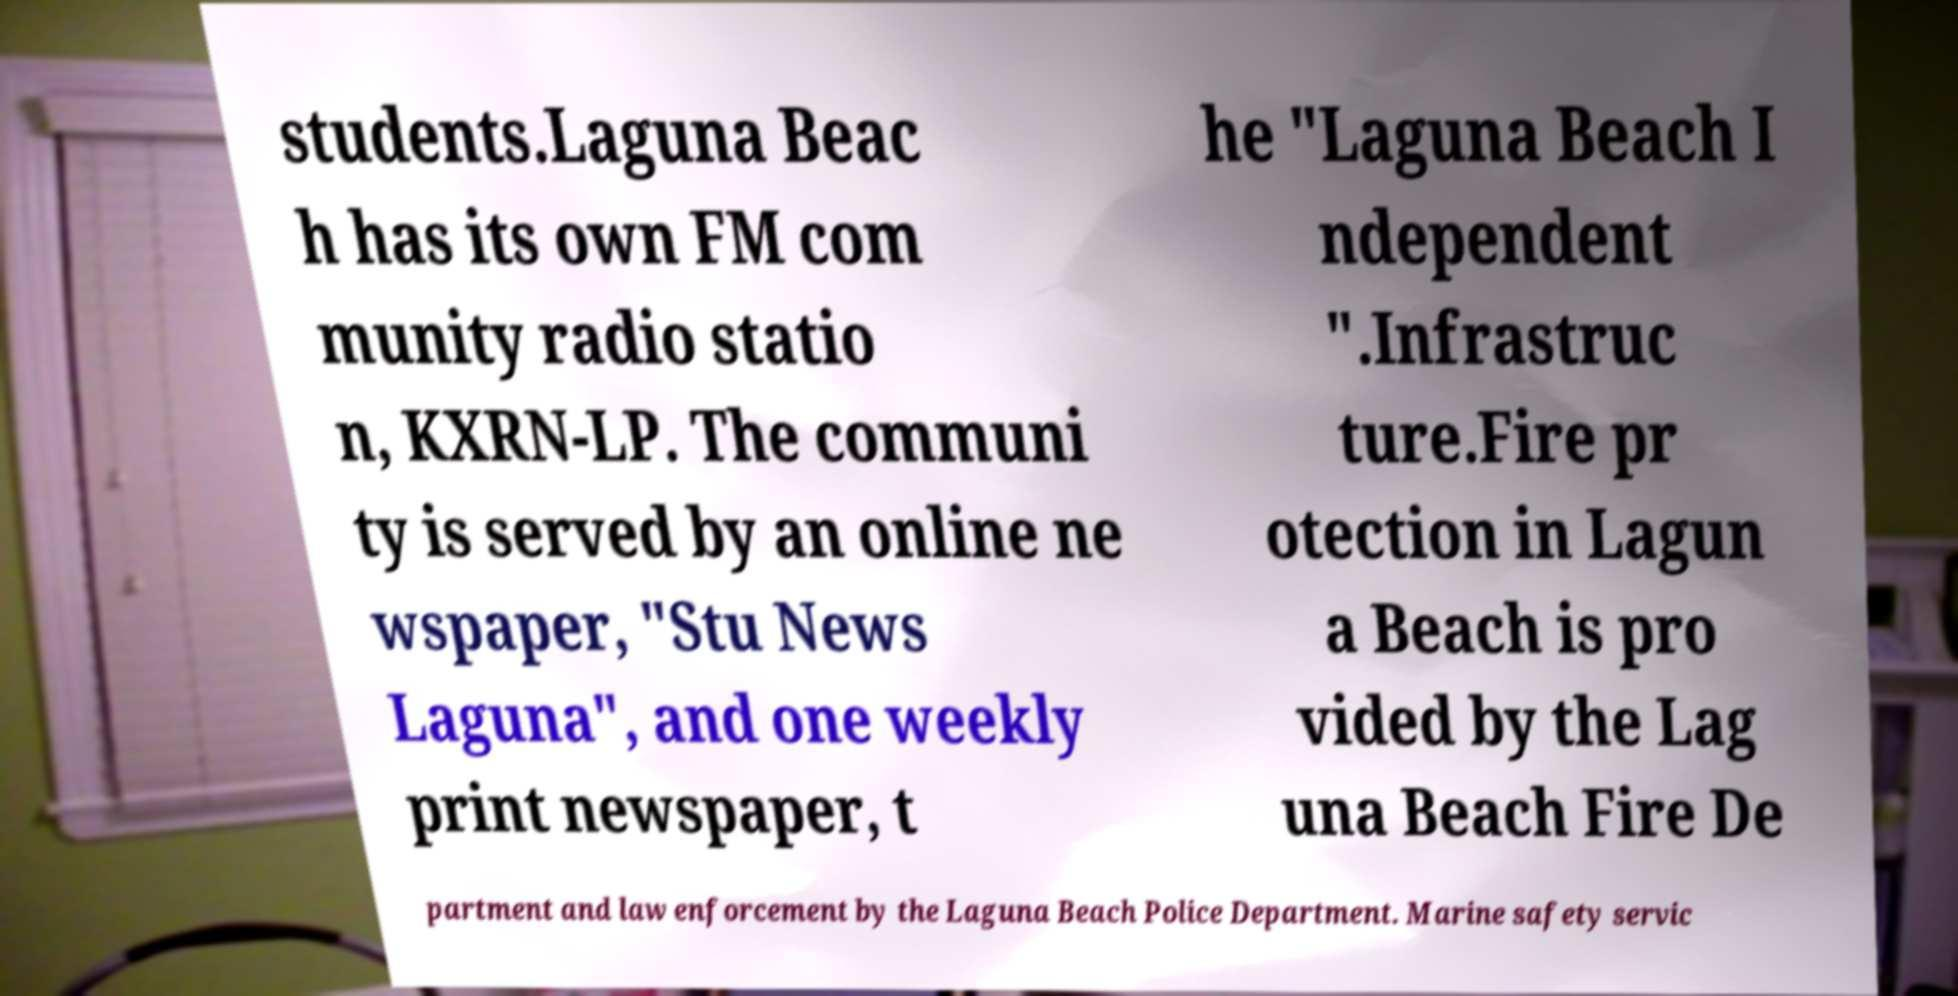Please identify and transcribe the text found in this image. students.Laguna Beac h has its own FM com munity radio statio n, KXRN-LP. The communi ty is served by an online ne wspaper, "Stu News Laguna", and one weekly print newspaper, t he "Laguna Beach I ndependent ".Infrastruc ture.Fire pr otection in Lagun a Beach is pro vided by the Lag una Beach Fire De partment and law enforcement by the Laguna Beach Police Department. Marine safety servic 